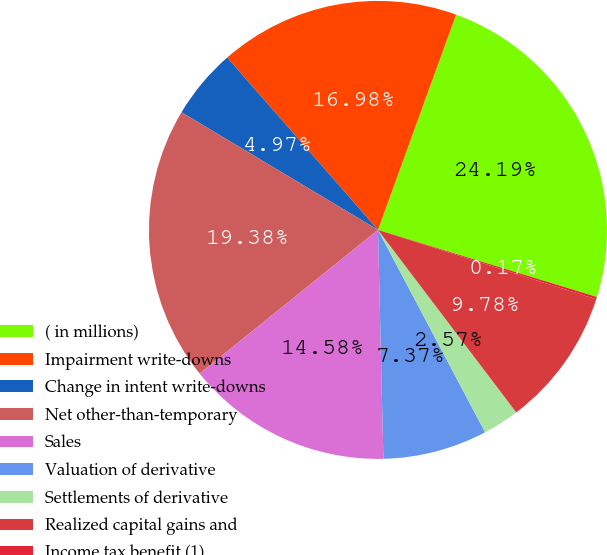Convert chart. <chart><loc_0><loc_0><loc_500><loc_500><pie_chart><fcel>( in millions)<fcel>Impairment write-downs<fcel>Change in intent write-downs<fcel>Net other-than-temporary<fcel>Sales<fcel>Valuation of derivative<fcel>Settlements of derivative<fcel>Realized capital gains and<fcel>Income tax benefit (1)<nl><fcel>24.19%<fcel>16.98%<fcel>4.97%<fcel>19.38%<fcel>14.58%<fcel>7.37%<fcel>2.57%<fcel>9.78%<fcel>0.17%<nl></chart> 